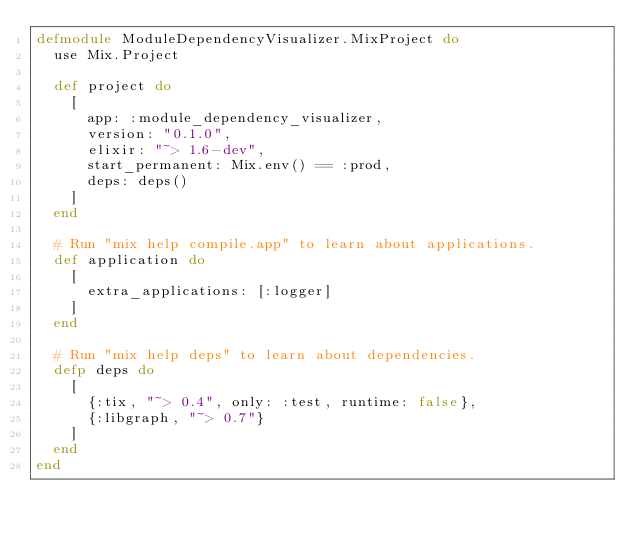Convert code to text. <code><loc_0><loc_0><loc_500><loc_500><_Elixir_>defmodule ModuleDependencyVisualizer.MixProject do
  use Mix.Project

  def project do
    [
      app: :module_dependency_visualizer,
      version: "0.1.0",
      elixir: "~> 1.6-dev",
      start_permanent: Mix.env() == :prod,
      deps: deps()
    ]
  end

  # Run "mix help compile.app" to learn about applications.
  def application do
    [
      extra_applications: [:logger]
    ]
  end

  # Run "mix help deps" to learn about dependencies.
  defp deps do
    [
      {:tix, "~> 0.4", only: :test, runtime: false},
      {:libgraph, "~> 0.7"}
    ]
  end
end
</code> 